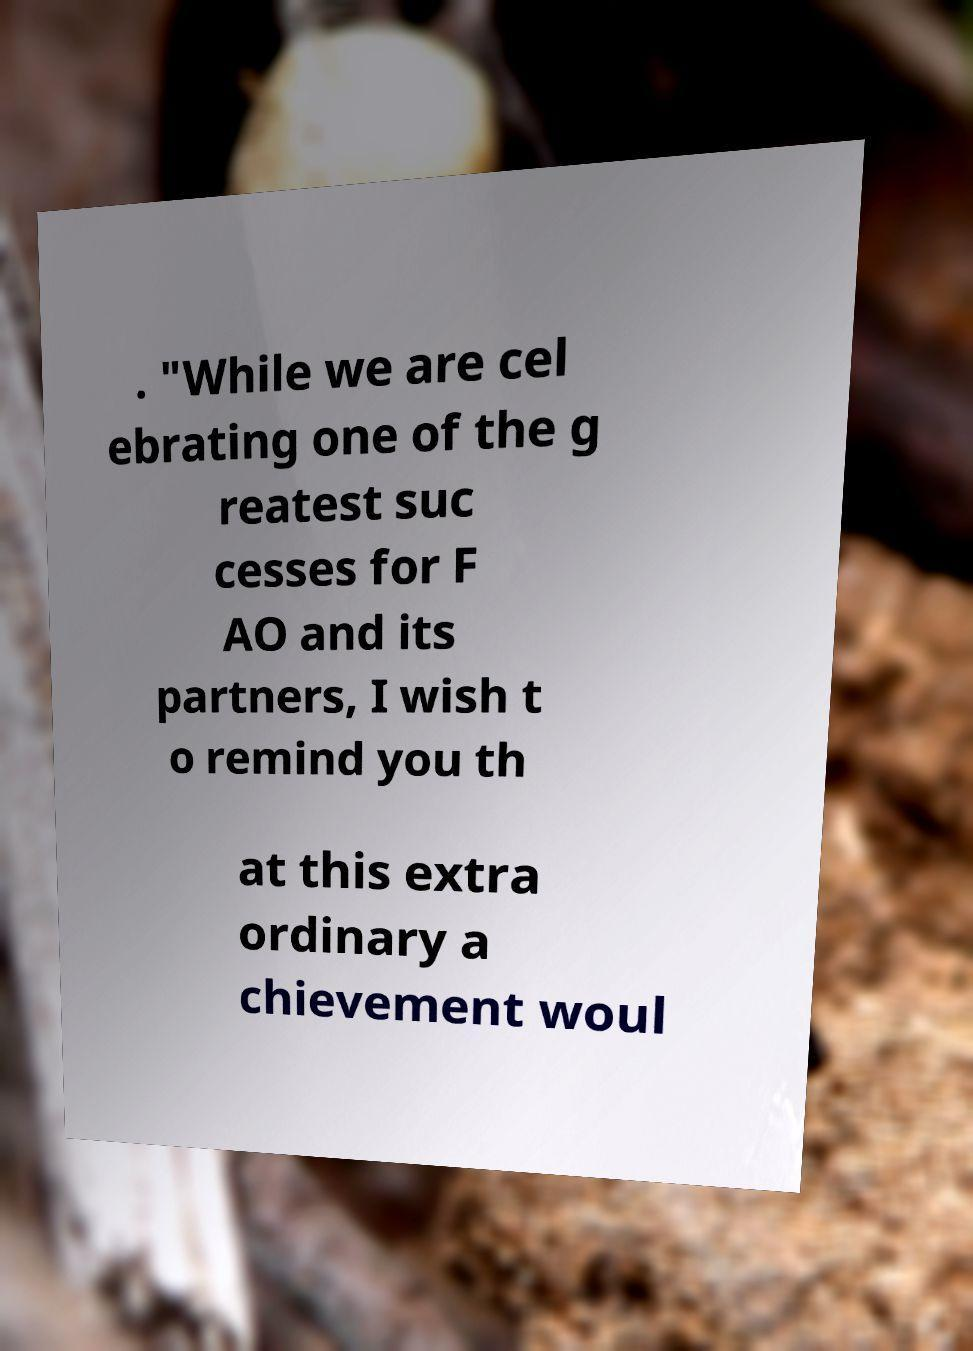I need the written content from this picture converted into text. Can you do that? . "While we are cel ebrating one of the g reatest suc cesses for F AO and its partners, I wish t o remind you th at this extra ordinary a chievement woul 